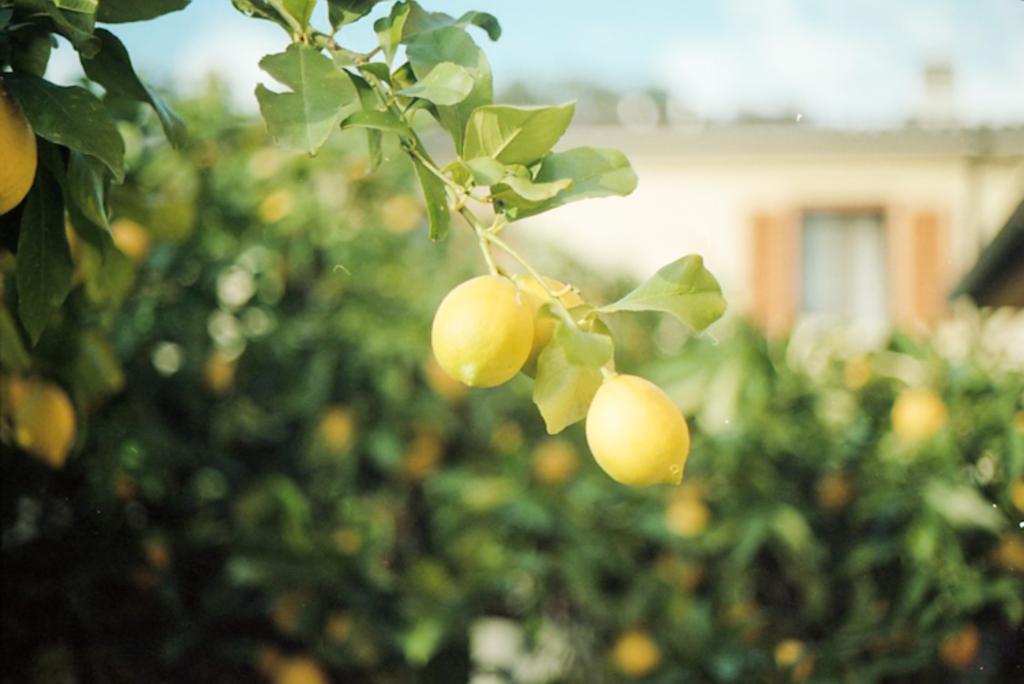Could you give a brief overview of what you see in this image? In this image I can see lemon trees, a building, the sky and I can also see this image is blurry in the background. 